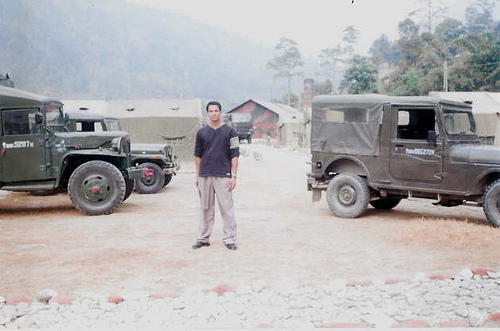Can you tell me more about the vehicles in the picture? The image features two military-looking vehicles, possibly jeeps, with what seems like canvas covers over the rear compartments. Their sturdy designs suggest they are meant for rough terrains. The presence of these vehicles might imply a military facility or activity in the area or perhaps an adventurous off-road excursion. 